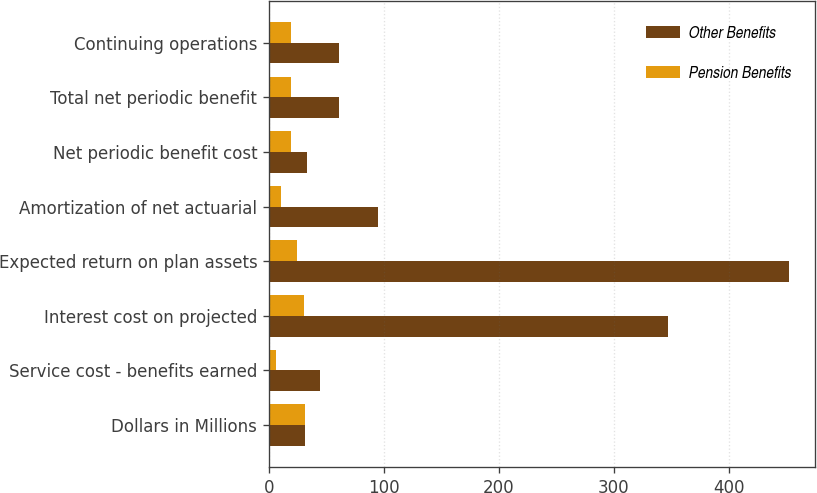Convert chart to OTSL. <chart><loc_0><loc_0><loc_500><loc_500><stacked_bar_chart><ecel><fcel>Dollars in Millions<fcel>Service cost - benefits earned<fcel>Interest cost on projected<fcel>Expected return on plan assets<fcel>Amortization of net actuarial<fcel>Net periodic benefit cost<fcel>Total net periodic benefit<fcel>Continuing operations<nl><fcel>Other Benefits<fcel>31.5<fcel>44<fcel>347<fcel>453<fcel>95<fcel>33<fcel>61<fcel>61<nl><fcel>Pension Benefits<fcel>31.5<fcel>6<fcel>30<fcel>24<fcel>10<fcel>19<fcel>19<fcel>19<nl></chart> 